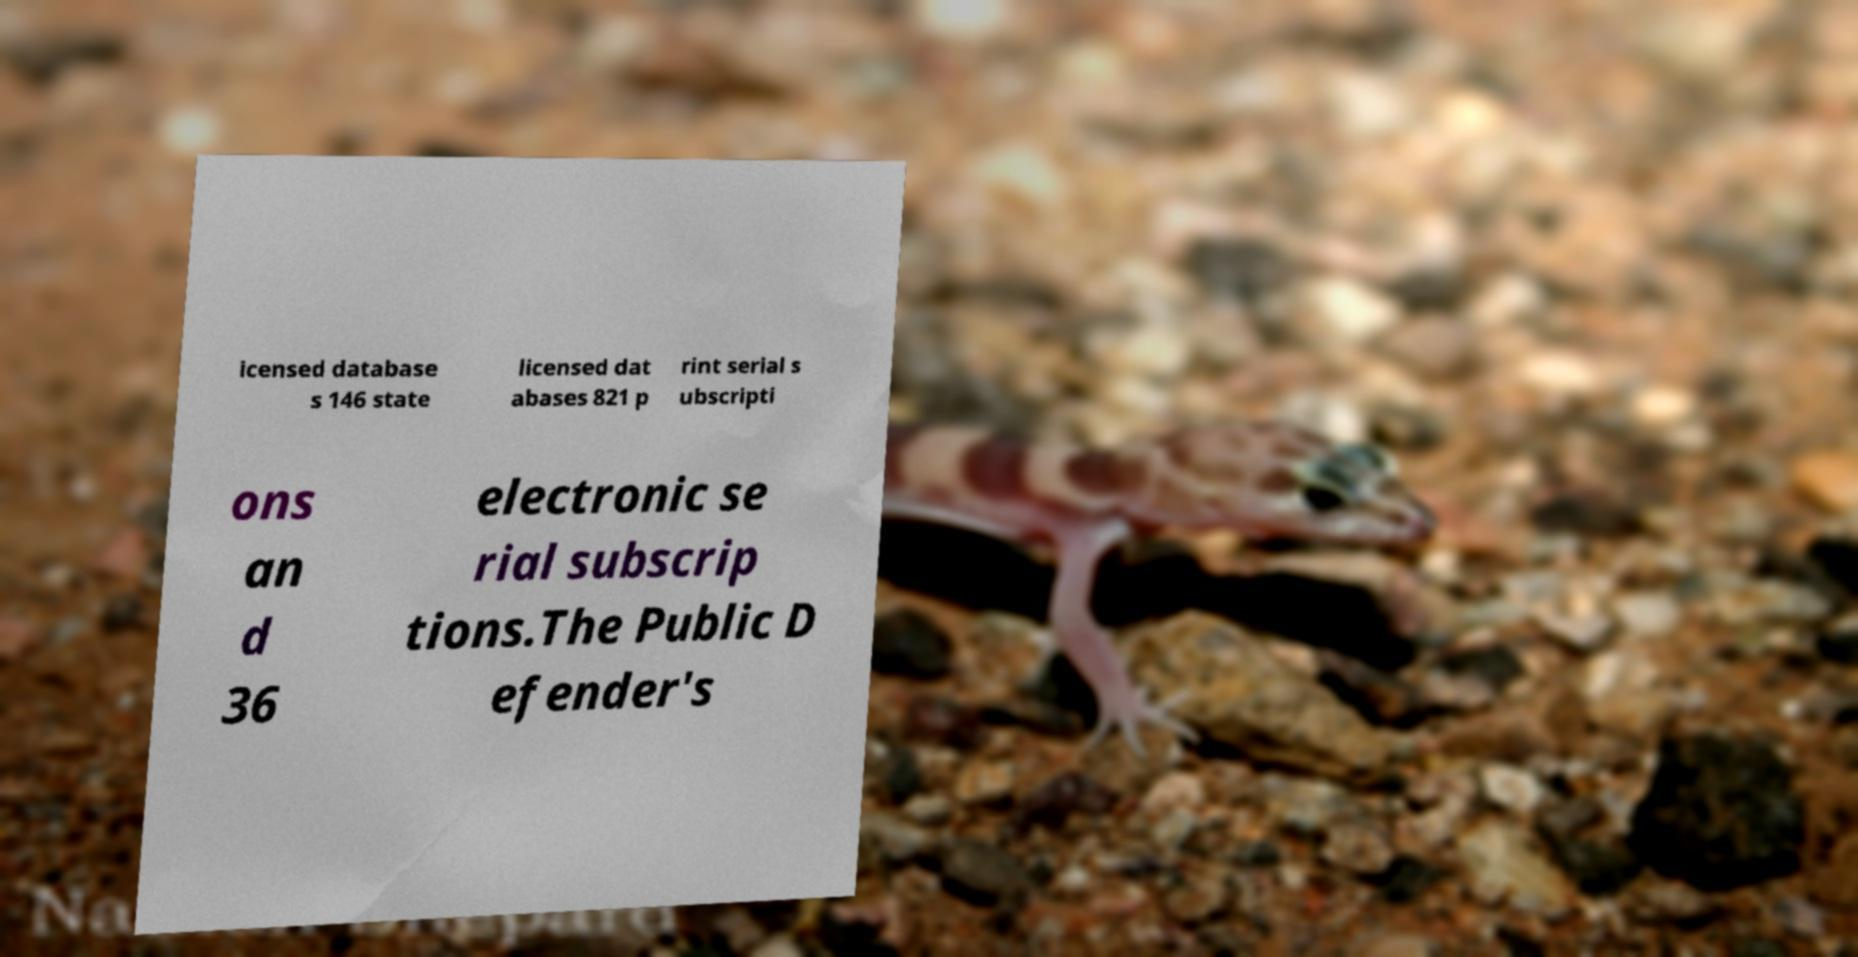Could you extract and type out the text from this image? icensed database s 146 state licensed dat abases 821 p rint serial s ubscripti ons an d 36 electronic se rial subscrip tions.The Public D efender's 